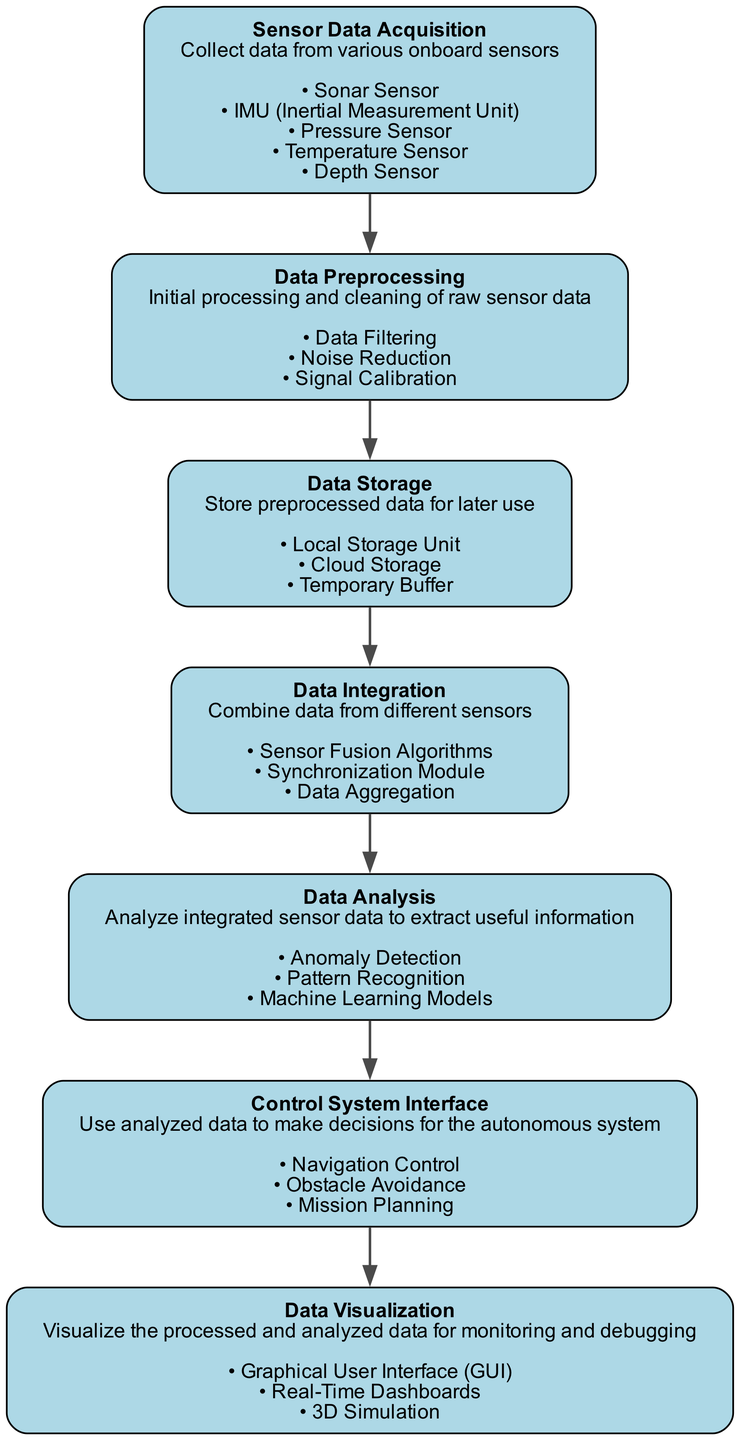What is the first element in the data pipeline? The first element listed in the diagram is "Sensor Data Acquisition," which is responsible for collecting data from various onboard sensors.
Answer: Sensor Data Acquisition How many components does the "Data Analysis" module have? By inspecting the "Data Analysis" module, we see three components listed: Anomaly Detection, Pattern Recognition, and Machine Learning Models.
Answer: 3 Which element follows "Data Preprocessing"? The element directly connected and following "Data Preprocessing" in the sequence is "Data Storage," indicating the order of operations in the pipeline.
Answer: Data Storage What is the primary function of the "Control System Interface"? The "Control System Interface" is tasked with making decisions for the autonomous system using the analyzed data, which includes Navigation Control, Obstacle Avoidance, and Mission Planning.
Answer: Use analyzed data Which components are involved in the "Data Integration" stage? The "Data Integration" stage includes three specific components: Sensor Fusion Algorithms, Synchronization Module, and Data Aggregation to combine data from different sensors.
Answer: Sensor Fusion Algorithms, Synchronization Module, Data Aggregation In what order do the components of the "Data Preprocessing" module appear? The components of the "Data Preprocessing" module appear in this order: Data Filtering, Noise Reduction, and Signal Calibration, which collectively enhance the quality of the sensor data before further processing.
Answer: Data Filtering, Noise Reduction, Signal Calibration How are the elements connected in the diagram? Each element is connected sequentially, illustrating a flow from "Sensor Data Acquisition" down to "Data Visualization," depicting the progression of data processing steps in the pipeline.
Answer: Sequentially What type of algorithms does the "Data Analysis" stage utilize? The "Data Analysis" stage employs algorithms focused on Anomaly Detection, Pattern Recognition, and Machine Learning Models to analyze sensor data effectively.
Answer: Anomaly Detection, Pattern Recognition, Machine Learning Models 